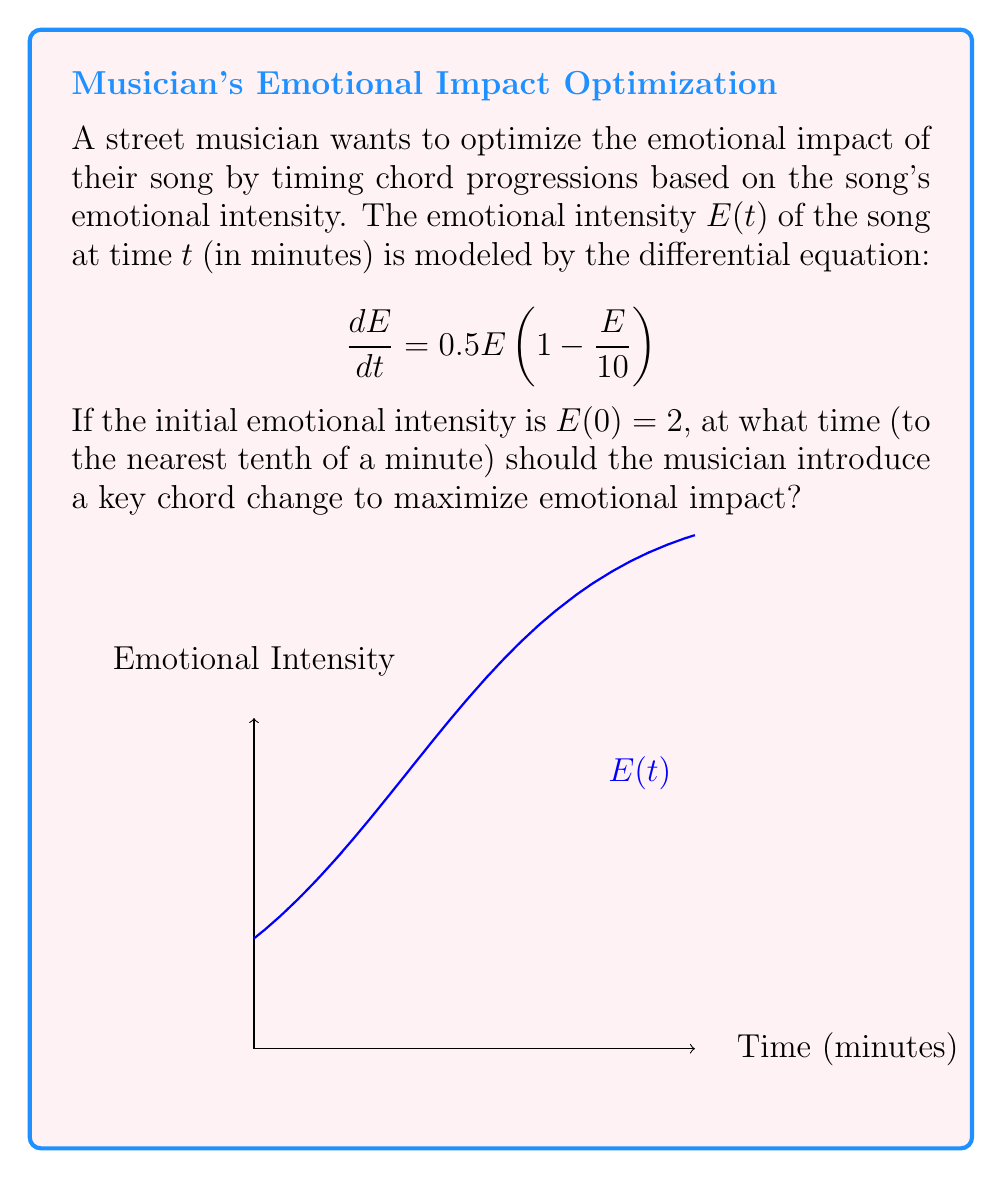Could you help me with this problem? To solve this problem, we need to follow these steps:

1) The given differential equation is a logistic growth model:
   $$\frac{dE}{dt} = 0.5E(1 - \frac{E}{10})$$

2) The solution to this equation is:
   $$E(t) = \frac{10}{1 + Ce^{-0.5t}}$$
   where $C$ is a constant determined by the initial condition.

3) Using the initial condition $E(0) = 2$, we can find $C$:
   $$2 = \frac{10}{1 + C}$$
   $$C = 4$$

4) So our specific solution is:
   $$E(t) = \frac{10}{1 + 4e^{-0.5t}}$$

5) To find the time of maximum growth (inflection point), we need to find when $\frac{d^2E}{dt^2} = 0$.

6) First, let's find $\frac{dE}{dt}$:
   $$\frac{dE}{dt} = \frac{20e^{-0.5t}}{(1 + 4e^{-0.5t})^2}$$

7) Now, let's find $\frac{d^2E}{dt^2}$ and set it to zero:
   $$\frac{d^2E}{dt^2} = \frac{20e^{-0.5t}(-0.5)(1 + 4e^{-0.5t})^2 - 2(20e^{-0.5t})^2(-2e^{-0.5t})(-0.5)}{(1 + 4e^{-0.5t})^4} = 0$$

8) Simplifying, we get:
   $$-0.5(1 + 4e^{-0.5t})^2 + 40e^{-0.5t} = 0$$
   $$(1 + 4e^{-0.5t})^2 = 80e^{-0.5t}$$
   $$1 + 8e^{-0.5t} + 16e^{-t} = 80e^{-0.5t}$$
   $$1 + 16e^{-t} = 72e^{-0.5t}$$

9) This is satisfied when $e^{-0.5t} = 3$, or when $t = \frac{2\ln(3)}{0.5} \approx 4.4$ minutes.

Therefore, the musician should introduce a key chord change at approximately 4.4 minutes to maximize emotional impact.
Answer: 4.4 minutes 